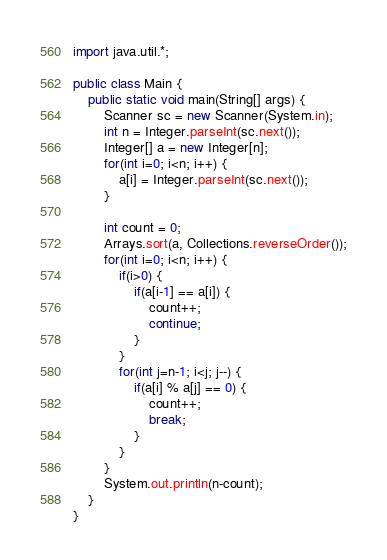Convert code to text. <code><loc_0><loc_0><loc_500><loc_500><_Java_>import java.util.*;

public class Main {
    public static void main(String[] args) {
        Scanner sc = new Scanner(System.in);
        int n = Integer.parseInt(sc.next());
        Integer[] a = new Integer[n];
        for(int i=0; i<n; i++) {
            a[i] = Integer.parseInt(sc.next());
        }
        
        int count = 0;
        Arrays.sort(a, Collections.reverseOrder());
        for(int i=0; i<n; i++) {
            if(i>0) {
                if(a[i-1] == a[i]) {
                    count++;
                    continue;
                }
            }
            for(int j=n-1; i<j; j--) {
                if(a[i] % a[j] == 0) {
                    count++;
                    break;
                }
            }
        }
        System.out.println(n-count);
    }
}</code> 